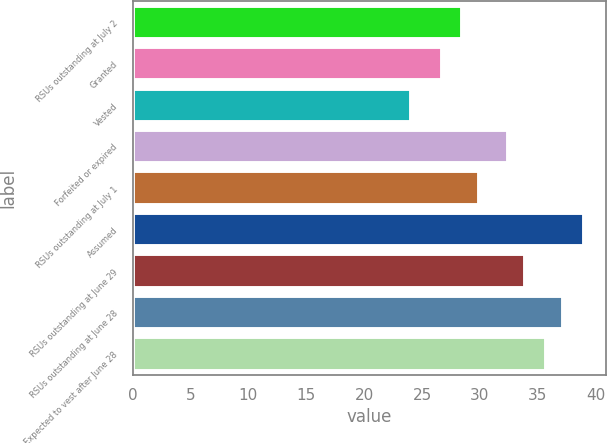Convert chart to OTSL. <chart><loc_0><loc_0><loc_500><loc_500><bar_chart><fcel>RSUs outstanding at July 2<fcel>Granted<fcel>Vested<fcel>Forfeited or expired<fcel>RSUs outstanding at July 1<fcel>Assumed<fcel>RSUs outstanding at June 29<fcel>RSUs outstanding at June 28<fcel>Expected to vest after June 28<nl><fcel>28.43<fcel>26.75<fcel>24.03<fcel>32.41<fcel>29.93<fcel>38.98<fcel>33.9<fcel>37.17<fcel>35.68<nl></chart> 